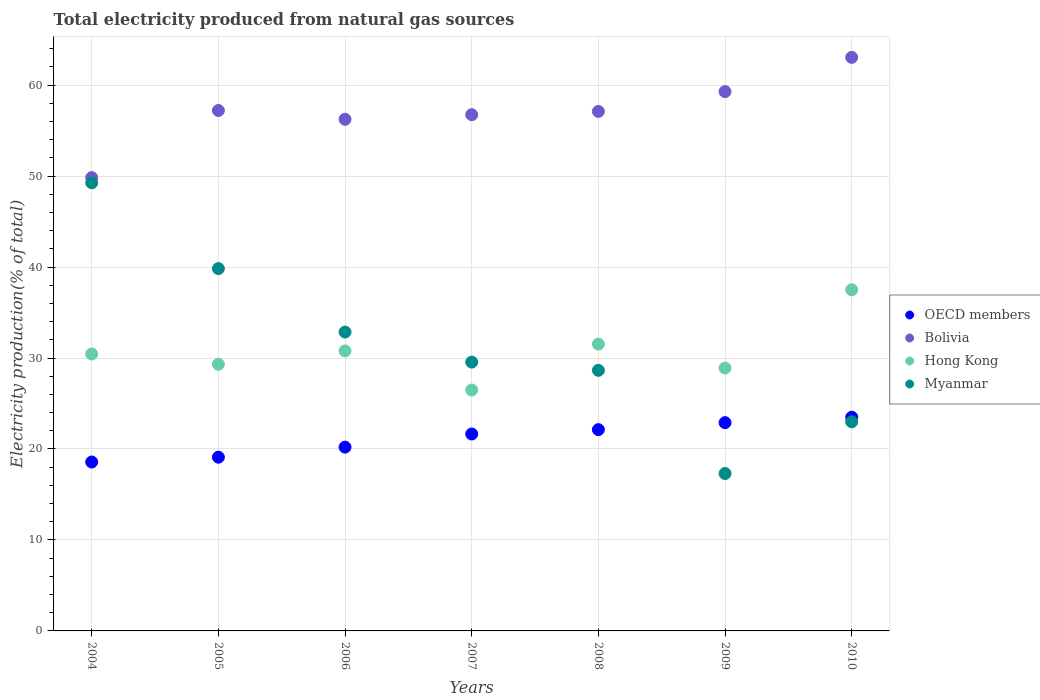How many different coloured dotlines are there?
Your answer should be very brief. 4. Is the number of dotlines equal to the number of legend labels?
Give a very brief answer. Yes. What is the total electricity produced in OECD members in 2008?
Give a very brief answer. 22.13. Across all years, what is the maximum total electricity produced in Hong Kong?
Give a very brief answer. 37.5. Across all years, what is the minimum total electricity produced in OECD members?
Keep it short and to the point. 18.57. In which year was the total electricity produced in Hong Kong maximum?
Offer a very short reply. 2010. In which year was the total electricity produced in Myanmar minimum?
Offer a very short reply. 2009. What is the total total electricity produced in Hong Kong in the graph?
Provide a succinct answer. 214.95. What is the difference between the total electricity produced in Hong Kong in 2006 and that in 2009?
Provide a succinct answer. 1.89. What is the difference between the total electricity produced in Bolivia in 2004 and the total electricity produced in Myanmar in 2010?
Provide a succinct answer. 26.85. What is the average total electricity produced in OECD members per year?
Keep it short and to the point. 21.15. In the year 2006, what is the difference between the total electricity produced in Hong Kong and total electricity produced in OECD members?
Offer a very short reply. 10.58. What is the ratio of the total electricity produced in Hong Kong in 2005 to that in 2008?
Ensure brevity in your answer.  0.93. Is the difference between the total electricity produced in Hong Kong in 2005 and 2007 greater than the difference between the total electricity produced in OECD members in 2005 and 2007?
Keep it short and to the point. Yes. What is the difference between the highest and the second highest total electricity produced in Bolivia?
Ensure brevity in your answer.  3.76. What is the difference between the highest and the lowest total electricity produced in OECD members?
Your answer should be compact. 4.93. In how many years, is the total electricity produced in Bolivia greater than the average total electricity produced in Bolivia taken over all years?
Make the answer very short. 4. Is the sum of the total electricity produced in Bolivia in 2005 and 2006 greater than the maximum total electricity produced in Hong Kong across all years?
Offer a very short reply. Yes. Is it the case that in every year, the sum of the total electricity produced in OECD members and total electricity produced in Myanmar  is greater than the sum of total electricity produced in Hong Kong and total electricity produced in Bolivia?
Give a very brief answer. No. Is the total electricity produced in OECD members strictly greater than the total electricity produced in Bolivia over the years?
Give a very brief answer. No. Is the total electricity produced in Hong Kong strictly less than the total electricity produced in Bolivia over the years?
Offer a terse response. Yes. How many dotlines are there?
Give a very brief answer. 4. Does the graph contain grids?
Keep it short and to the point. Yes. Where does the legend appear in the graph?
Give a very brief answer. Center right. How many legend labels are there?
Offer a terse response. 4. How are the legend labels stacked?
Your response must be concise. Vertical. What is the title of the graph?
Give a very brief answer. Total electricity produced from natural gas sources. Does "Kosovo" appear as one of the legend labels in the graph?
Offer a very short reply. No. What is the label or title of the X-axis?
Offer a very short reply. Years. What is the label or title of the Y-axis?
Provide a succinct answer. Electricity production(% of total). What is the Electricity production(% of total) in OECD members in 2004?
Make the answer very short. 18.57. What is the Electricity production(% of total) of Bolivia in 2004?
Provide a succinct answer. 49.83. What is the Electricity production(% of total) in Hong Kong in 2004?
Your response must be concise. 30.44. What is the Electricity production(% of total) in Myanmar in 2004?
Your answer should be very brief. 49.26. What is the Electricity production(% of total) of OECD members in 2005?
Keep it short and to the point. 19.1. What is the Electricity production(% of total) of Bolivia in 2005?
Give a very brief answer. 57.21. What is the Electricity production(% of total) in Hong Kong in 2005?
Offer a very short reply. 29.31. What is the Electricity production(% of total) in Myanmar in 2005?
Your answer should be compact. 39.83. What is the Electricity production(% of total) in OECD members in 2006?
Provide a succinct answer. 20.2. What is the Electricity production(% of total) of Bolivia in 2006?
Provide a short and direct response. 56.25. What is the Electricity production(% of total) of Hong Kong in 2006?
Offer a very short reply. 30.78. What is the Electricity production(% of total) of Myanmar in 2006?
Your answer should be very brief. 32.85. What is the Electricity production(% of total) in OECD members in 2007?
Provide a short and direct response. 21.65. What is the Electricity production(% of total) of Bolivia in 2007?
Provide a succinct answer. 56.75. What is the Electricity production(% of total) of Hong Kong in 2007?
Your answer should be very brief. 26.48. What is the Electricity production(% of total) of Myanmar in 2007?
Your answer should be very brief. 29.55. What is the Electricity production(% of total) in OECD members in 2008?
Keep it short and to the point. 22.13. What is the Electricity production(% of total) of Bolivia in 2008?
Make the answer very short. 57.11. What is the Electricity production(% of total) in Hong Kong in 2008?
Offer a very short reply. 31.53. What is the Electricity production(% of total) of Myanmar in 2008?
Provide a succinct answer. 28.65. What is the Electricity production(% of total) in OECD members in 2009?
Offer a terse response. 22.9. What is the Electricity production(% of total) of Bolivia in 2009?
Provide a short and direct response. 59.29. What is the Electricity production(% of total) of Hong Kong in 2009?
Make the answer very short. 28.9. What is the Electricity production(% of total) in Myanmar in 2009?
Provide a succinct answer. 17.3. What is the Electricity production(% of total) of OECD members in 2010?
Offer a very short reply. 23.49. What is the Electricity production(% of total) in Bolivia in 2010?
Offer a very short reply. 63.05. What is the Electricity production(% of total) of Hong Kong in 2010?
Offer a terse response. 37.5. What is the Electricity production(% of total) in Myanmar in 2010?
Provide a succinct answer. 22.99. Across all years, what is the maximum Electricity production(% of total) of OECD members?
Give a very brief answer. 23.49. Across all years, what is the maximum Electricity production(% of total) in Bolivia?
Keep it short and to the point. 63.05. Across all years, what is the maximum Electricity production(% of total) of Hong Kong?
Provide a short and direct response. 37.5. Across all years, what is the maximum Electricity production(% of total) in Myanmar?
Make the answer very short. 49.26. Across all years, what is the minimum Electricity production(% of total) of OECD members?
Ensure brevity in your answer.  18.57. Across all years, what is the minimum Electricity production(% of total) of Bolivia?
Make the answer very short. 49.83. Across all years, what is the minimum Electricity production(% of total) in Hong Kong?
Ensure brevity in your answer.  26.48. Across all years, what is the minimum Electricity production(% of total) of Myanmar?
Ensure brevity in your answer.  17.3. What is the total Electricity production(% of total) of OECD members in the graph?
Your answer should be very brief. 148.03. What is the total Electricity production(% of total) of Bolivia in the graph?
Provide a short and direct response. 399.48. What is the total Electricity production(% of total) of Hong Kong in the graph?
Offer a terse response. 214.95. What is the total Electricity production(% of total) of Myanmar in the graph?
Ensure brevity in your answer.  220.43. What is the difference between the Electricity production(% of total) in OECD members in 2004 and that in 2005?
Provide a short and direct response. -0.53. What is the difference between the Electricity production(% of total) of Bolivia in 2004 and that in 2005?
Provide a succinct answer. -7.38. What is the difference between the Electricity production(% of total) in Hong Kong in 2004 and that in 2005?
Offer a terse response. 1.13. What is the difference between the Electricity production(% of total) of Myanmar in 2004 and that in 2005?
Provide a succinct answer. 9.43. What is the difference between the Electricity production(% of total) in OECD members in 2004 and that in 2006?
Your answer should be compact. -1.64. What is the difference between the Electricity production(% of total) of Bolivia in 2004 and that in 2006?
Your response must be concise. -6.41. What is the difference between the Electricity production(% of total) of Hong Kong in 2004 and that in 2006?
Provide a short and direct response. -0.34. What is the difference between the Electricity production(% of total) in Myanmar in 2004 and that in 2006?
Your answer should be very brief. 16.41. What is the difference between the Electricity production(% of total) of OECD members in 2004 and that in 2007?
Your response must be concise. -3.08. What is the difference between the Electricity production(% of total) of Bolivia in 2004 and that in 2007?
Provide a short and direct response. -6.92. What is the difference between the Electricity production(% of total) of Hong Kong in 2004 and that in 2007?
Offer a terse response. 3.96. What is the difference between the Electricity production(% of total) of Myanmar in 2004 and that in 2007?
Make the answer very short. 19.71. What is the difference between the Electricity production(% of total) in OECD members in 2004 and that in 2008?
Keep it short and to the point. -3.56. What is the difference between the Electricity production(% of total) of Bolivia in 2004 and that in 2008?
Offer a terse response. -7.27. What is the difference between the Electricity production(% of total) in Hong Kong in 2004 and that in 2008?
Provide a succinct answer. -1.09. What is the difference between the Electricity production(% of total) in Myanmar in 2004 and that in 2008?
Your answer should be compact. 20.61. What is the difference between the Electricity production(% of total) in OECD members in 2004 and that in 2009?
Your response must be concise. -4.33. What is the difference between the Electricity production(% of total) of Bolivia in 2004 and that in 2009?
Ensure brevity in your answer.  -9.45. What is the difference between the Electricity production(% of total) of Hong Kong in 2004 and that in 2009?
Offer a terse response. 1.55. What is the difference between the Electricity production(% of total) in Myanmar in 2004 and that in 2009?
Your answer should be compact. 31.96. What is the difference between the Electricity production(% of total) in OECD members in 2004 and that in 2010?
Keep it short and to the point. -4.93. What is the difference between the Electricity production(% of total) in Bolivia in 2004 and that in 2010?
Give a very brief answer. -13.21. What is the difference between the Electricity production(% of total) of Hong Kong in 2004 and that in 2010?
Your answer should be compact. -7.06. What is the difference between the Electricity production(% of total) in Myanmar in 2004 and that in 2010?
Your answer should be compact. 26.27. What is the difference between the Electricity production(% of total) of OECD members in 2005 and that in 2006?
Your answer should be very brief. -1.11. What is the difference between the Electricity production(% of total) in Bolivia in 2005 and that in 2006?
Ensure brevity in your answer.  0.96. What is the difference between the Electricity production(% of total) in Hong Kong in 2005 and that in 2006?
Give a very brief answer. -1.47. What is the difference between the Electricity production(% of total) of Myanmar in 2005 and that in 2006?
Provide a succinct answer. 6.98. What is the difference between the Electricity production(% of total) in OECD members in 2005 and that in 2007?
Make the answer very short. -2.55. What is the difference between the Electricity production(% of total) in Bolivia in 2005 and that in 2007?
Provide a short and direct response. 0.46. What is the difference between the Electricity production(% of total) in Hong Kong in 2005 and that in 2007?
Your answer should be very brief. 2.83. What is the difference between the Electricity production(% of total) of Myanmar in 2005 and that in 2007?
Make the answer very short. 10.28. What is the difference between the Electricity production(% of total) in OECD members in 2005 and that in 2008?
Give a very brief answer. -3.03. What is the difference between the Electricity production(% of total) in Bolivia in 2005 and that in 2008?
Offer a terse response. 0.1. What is the difference between the Electricity production(% of total) of Hong Kong in 2005 and that in 2008?
Keep it short and to the point. -2.22. What is the difference between the Electricity production(% of total) in Myanmar in 2005 and that in 2008?
Give a very brief answer. 11.18. What is the difference between the Electricity production(% of total) of OECD members in 2005 and that in 2009?
Ensure brevity in your answer.  -3.8. What is the difference between the Electricity production(% of total) in Bolivia in 2005 and that in 2009?
Offer a very short reply. -2.08. What is the difference between the Electricity production(% of total) of Hong Kong in 2005 and that in 2009?
Give a very brief answer. 0.41. What is the difference between the Electricity production(% of total) in Myanmar in 2005 and that in 2009?
Your response must be concise. 22.52. What is the difference between the Electricity production(% of total) of OECD members in 2005 and that in 2010?
Ensure brevity in your answer.  -4.4. What is the difference between the Electricity production(% of total) of Bolivia in 2005 and that in 2010?
Ensure brevity in your answer.  -5.84. What is the difference between the Electricity production(% of total) in Hong Kong in 2005 and that in 2010?
Keep it short and to the point. -8.19. What is the difference between the Electricity production(% of total) in Myanmar in 2005 and that in 2010?
Your response must be concise. 16.84. What is the difference between the Electricity production(% of total) in OECD members in 2006 and that in 2007?
Your answer should be compact. -1.44. What is the difference between the Electricity production(% of total) in Bolivia in 2006 and that in 2007?
Your response must be concise. -0.5. What is the difference between the Electricity production(% of total) of Hong Kong in 2006 and that in 2007?
Offer a terse response. 4.3. What is the difference between the Electricity production(% of total) of Myanmar in 2006 and that in 2007?
Give a very brief answer. 3.3. What is the difference between the Electricity production(% of total) of OECD members in 2006 and that in 2008?
Your response must be concise. -1.92. What is the difference between the Electricity production(% of total) in Bolivia in 2006 and that in 2008?
Offer a very short reply. -0.86. What is the difference between the Electricity production(% of total) of Hong Kong in 2006 and that in 2008?
Offer a terse response. -0.75. What is the difference between the Electricity production(% of total) in Myanmar in 2006 and that in 2008?
Give a very brief answer. 4.21. What is the difference between the Electricity production(% of total) in OECD members in 2006 and that in 2009?
Offer a very short reply. -2.69. What is the difference between the Electricity production(% of total) in Bolivia in 2006 and that in 2009?
Your response must be concise. -3.04. What is the difference between the Electricity production(% of total) of Hong Kong in 2006 and that in 2009?
Your answer should be very brief. 1.89. What is the difference between the Electricity production(% of total) of Myanmar in 2006 and that in 2009?
Your answer should be compact. 15.55. What is the difference between the Electricity production(% of total) in OECD members in 2006 and that in 2010?
Your response must be concise. -3.29. What is the difference between the Electricity production(% of total) of Bolivia in 2006 and that in 2010?
Provide a succinct answer. -6.8. What is the difference between the Electricity production(% of total) of Hong Kong in 2006 and that in 2010?
Your answer should be compact. -6.72. What is the difference between the Electricity production(% of total) in Myanmar in 2006 and that in 2010?
Give a very brief answer. 9.86. What is the difference between the Electricity production(% of total) in OECD members in 2007 and that in 2008?
Provide a succinct answer. -0.48. What is the difference between the Electricity production(% of total) of Bolivia in 2007 and that in 2008?
Ensure brevity in your answer.  -0.36. What is the difference between the Electricity production(% of total) in Hong Kong in 2007 and that in 2008?
Provide a short and direct response. -5.05. What is the difference between the Electricity production(% of total) of Myanmar in 2007 and that in 2008?
Make the answer very short. 0.9. What is the difference between the Electricity production(% of total) in OECD members in 2007 and that in 2009?
Keep it short and to the point. -1.25. What is the difference between the Electricity production(% of total) of Bolivia in 2007 and that in 2009?
Make the answer very short. -2.54. What is the difference between the Electricity production(% of total) in Hong Kong in 2007 and that in 2009?
Provide a succinct answer. -2.41. What is the difference between the Electricity production(% of total) of Myanmar in 2007 and that in 2009?
Make the answer very short. 12.25. What is the difference between the Electricity production(% of total) in OECD members in 2007 and that in 2010?
Provide a succinct answer. -1.85. What is the difference between the Electricity production(% of total) of Bolivia in 2007 and that in 2010?
Keep it short and to the point. -6.3. What is the difference between the Electricity production(% of total) of Hong Kong in 2007 and that in 2010?
Your response must be concise. -11.02. What is the difference between the Electricity production(% of total) in Myanmar in 2007 and that in 2010?
Your answer should be very brief. 6.56. What is the difference between the Electricity production(% of total) of OECD members in 2008 and that in 2009?
Your response must be concise. -0.77. What is the difference between the Electricity production(% of total) of Bolivia in 2008 and that in 2009?
Offer a terse response. -2.18. What is the difference between the Electricity production(% of total) of Hong Kong in 2008 and that in 2009?
Your answer should be compact. 2.64. What is the difference between the Electricity production(% of total) in Myanmar in 2008 and that in 2009?
Keep it short and to the point. 11.34. What is the difference between the Electricity production(% of total) in OECD members in 2008 and that in 2010?
Ensure brevity in your answer.  -1.37. What is the difference between the Electricity production(% of total) in Bolivia in 2008 and that in 2010?
Your answer should be compact. -5.94. What is the difference between the Electricity production(% of total) of Hong Kong in 2008 and that in 2010?
Keep it short and to the point. -5.97. What is the difference between the Electricity production(% of total) of Myanmar in 2008 and that in 2010?
Offer a very short reply. 5.66. What is the difference between the Electricity production(% of total) in OECD members in 2009 and that in 2010?
Ensure brevity in your answer.  -0.6. What is the difference between the Electricity production(% of total) in Bolivia in 2009 and that in 2010?
Make the answer very short. -3.76. What is the difference between the Electricity production(% of total) of Hong Kong in 2009 and that in 2010?
Provide a succinct answer. -8.61. What is the difference between the Electricity production(% of total) of Myanmar in 2009 and that in 2010?
Offer a very short reply. -5.68. What is the difference between the Electricity production(% of total) in OECD members in 2004 and the Electricity production(% of total) in Bolivia in 2005?
Offer a terse response. -38.64. What is the difference between the Electricity production(% of total) in OECD members in 2004 and the Electricity production(% of total) in Hong Kong in 2005?
Make the answer very short. -10.74. What is the difference between the Electricity production(% of total) of OECD members in 2004 and the Electricity production(% of total) of Myanmar in 2005?
Your answer should be very brief. -21.26. What is the difference between the Electricity production(% of total) of Bolivia in 2004 and the Electricity production(% of total) of Hong Kong in 2005?
Provide a succinct answer. 20.52. What is the difference between the Electricity production(% of total) of Bolivia in 2004 and the Electricity production(% of total) of Myanmar in 2005?
Give a very brief answer. 10.01. What is the difference between the Electricity production(% of total) of Hong Kong in 2004 and the Electricity production(% of total) of Myanmar in 2005?
Offer a terse response. -9.38. What is the difference between the Electricity production(% of total) of OECD members in 2004 and the Electricity production(% of total) of Bolivia in 2006?
Make the answer very short. -37.68. What is the difference between the Electricity production(% of total) in OECD members in 2004 and the Electricity production(% of total) in Hong Kong in 2006?
Your answer should be very brief. -12.22. What is the difference between the Electricity production(% of total) of OECD members in 2004 and the Electricity production(% of total) of Myanmar in 2006?
Offer a terse response. -14.29. What is the difference between the Electricity production(% of total) of Bolivia in 2004 and the Electricity production(% of total) of Hong Kong in 2006?
Provide a succinct answer. 19.05. What is the difference between the Electricity production(% of total) of Bolivia in 2004 and the Electricity production(% of total) of Myanmar in 2006?
Keep it short and to the point. 16.98. What is the difference between the Electricity production(% of total) of Hong Kong in 2004 and the Electricity production(% of total) of Myanmar in 2006?
Provide a succinct answer. -2.41. What is the difference between the Electricity production(% of total) of OECD members in 2004 and the Electricity production(% of total) of Bolivia in 2007?
Offer a terse response. -38.18. What is the difference between the Electricity production(% of total) of OECD members in 2004 and the Electricity production(% of total) of Hong Kong in 2007?
Your answer should be very brief. -7.92. What is the difference between the Electricity production(% of total) of OECD members in 2004 and the Electricity production(% of total) of Myanmar in 2007?
Keep it short and to the point. -10.98. What is the difference between the Electricity production(% of total) in Bolivia in 2004 and the Electricity production(% of total) in Hong Kong in 2007?
Your response must be concise. 23.35. What is the difference between the Electricity production(% of total) of Bolivia in 2004 and the Electricity production(% of total) of Myanmar in 2007?
Provide a short and direct response. 20.28. What is the difference between the Electricity production(% of total) in Hong Kong in 2004 and the Electricity production(% of total) in Myanmar in 2007?
Your response must be concise. 0.89. What is the difference between the Electricity production(% of total) of OECD members in 2004 and the Electricity production(% of total) of Bolivia in 2008?
Your answer should be very brief. -38.54. What is the difference between the Electricity production(% of total) in OECD members in 2004 and the Electricity production(% of total) in Hong Kong in 2008?
Offer a terse response. -12.96. What is the difference between the Electricity production(% of total) in OECD members in 2004 and the Electricity production(% of total) in Myanmar in 2008?
Make the answer very short. -10.08. What is the difference between the Electricity production(% of total) in Bolivia in 2004 and the Electricity production(% of total) in Hong Kong in 2008?
Offer a very short reply. 18.3. What is the difference between the Electricity production(% of total) of Bolivia in 2004 and the Electricity production(% of total) of Myanmar in 2008?
Make the answer very short. 21.19. What is the difference between the Electricity production(% of total) in Hong Kong in 2004 and the Electricity production(% of total) in Myanmar in 2008?
Ensure brevity in your answer.  1.8. What is the difference between the Electricity production(% of total) of OECD members in 2004 and the Electricity production(% of total) of Bolivia in 2009?
Offer a very short reply. -40.72. What is the difference between the Electricity production(% of total) in OECD members in 2004 and the Electricity production(% of total) in Hong Kong in 2009?
Your response must be concise. -10.33. What is the difference between the Electricity production(% of total) of OECD members in 2004 and the Electricity production(% of total) of Myanmar in 2009?
Ensure brevity in your answer.  1.26. What is the difference between the Electricity production(% of total) of Bolivia in 2004 and the Electricity production(% of total) of Hong Kong in 2009?
Provide a short and direct response. 20.94. What is the difference between the Electricity production(% of total) in Bolivia in 2004 and the Electricity production(% of total) in Myanmar in 2009?
Ensure brevity in your answer.  32.53. What is the difference between the Electricity production(% of total) in Hong Kong in 2004 and the Electricity production(% of total) in Myanmar in 2009?
Offer a terse response. 13.14. What is the difference between the Electricity production(% of total) in OECD members in 2004 and the Electricity production(% of total) in Bolivia in 2010?
Offer a very short reply. -44.48. What is the difference between the Electricity production(% of total) in OECD members in 2004 and the Electricity production(% of total) in Hong Kong in 2010?
Give a very brief answer. -18.94. What is the difference between the Electricity production(% of total) in OECD members in 2004 and the Electricity production(% of total) in Myanmar in 2010?
Your answer should be compact. -4.42. What is the difference between the Electricity production(% of total) in Bolivia in 2004 and the Electricity production(% of total) in Hong Kong in 2010?
Offer a terse response. 12.33. What is the difference between the Electricity production(% of total) in Bolivia in 2004 and the Electricity production(% of total) in Myanmar in 2010?
Keep it short and to the point. 26.85. What is the difference between the Electricity production(% of total) in Hong Kong in 2004 and the Electricity production(% of total) in Myanmar in 2010?
Provide a short and direct response. 7.45. What is the difference between the Electricity production(% of total) of OECD members in 2005 and the Electricity production(% of total) of Bolivia in 2006?
Offer a very short reply. -37.15. What is the difference between the Electricity production(% of total) of OECD members in 2005 and the Electricity production(% of total) of Hong Kong in 2006?
Ensure brevity in your answer.  -11.68. What is the difference between the Electricity production(% of total) in OECD members in 2005 and the Electricity production(% of total) in Myanmar in 2006?
Make the answer very short. -13.75. What is the difference between the Electricity production(% of total) in Bolivia in 2005 and the Electricity production(% of total) in Hong Kong in 2006?
Ensure brevity in your answer.  26.43. What is the difference between the Electricity production(% of total) in Bolivia in 2005 and the Electricity production(% of total) in Myanmar in 2006?
Offer a very short reply. 24.36. What is the difference between the Electricity production(% of total) of Hong Kong in 2005 and the Electricity production(% of total) of Myanmar in 2006?
Give a very brief answer. -3.54. What is the difference between the Electricity production(% of total) of OECD members in 2005 and the Electricity production(% of total) of Bolivia in 2007?
Provide a succinct answer. -37.65. What is the difference between the Electricity production(% of total) in OECD members in 2005 and the Electricity production(% of total) in Hong Kong in 2007?
Provide a short and direct response. -7.38. What is the difference between the Electricity production(% of total) in OECD members in 2005 and the Electricity production(% of total) in Myanmar in 2007?
Make the answer very short. -10.45. What is the difference between the Electricity production(% of total) in Bolivia in 2005 and the Electricity production(% of total) in Hong Kong in 2007?
Make the answer very short. 30.73. What is the difference between the Electricity production(% of total) of Bolivia in 2005 and the Electricity production(% of total) of Myanmar in 2007?
Provide a succinct answer. 27.66. What is the difference between the Electricity production(% of total) of Hong Kong in 2005 and the Electricity production(% of total) of Myanmar in 2007?
Your response must be concise. -0.24. What is the difference between the Electricity production(% of total) of OECD members in 2005 and the Electricity production(% of total) of Bolivia in 2008?
Your answer should be very brief. -38.01. What is the difference between the Electricity production(% of total) in OECD members in 2005 and the Electricity production(% of total) in Hong Kong in 2008?
Offer a terse response. -12.43. What is the difference between the Electricity production(% of total) in OECD members in 2005 and the Electricity production(% of total) in Myanmar in 2008?
Your response must be concise. -9.55. What is the difference between the Electricity production(% of total) in Bolivia in 2005 and the Electricity production(% of total) in Hong Kong in 2008?
Offer a terse response. 25.68. What is the difference between the Electricity production(% of total) in Bolivia in 2005 and the Electricity production(% of total) in Myanmar in 2008?
Ensure brevity in your answer.  28.56. What is the difference between the Electricity production(% of total) of Hong Kong in 2005 and the Electricity production(% of total) of Myanmar in 2008?
Offer a very short reply. 0.66. What is the difference between the Electricity production(% of total) in OECD members in 2005 and the Electricity production(% of total) in Bolivia in 2009?
Your answer should be very brief. -40.19. What is the difference between the Electricity production(% of total) in OECD members in 2005 and the Electricity production(% of total) in Hong Kong in 2009?
Offer a terse response. -9.8. What is the difference between the Electricity production(% of total) in OECD members in 2005 and the Electricity production(% of total) in Myanmar in 2009?
Make the answer very short. 1.8. What is the difference between the Electricity production(% of total) of Bolivia in 2005 and the Electricity production(% of total) of Hong Kong in 2009?
Provide a succinct answer. 28.31. What is the difference between the Electricity production(% of total) of Bolivia in 2005 and the Electricity production(% of total) of Myanmar in 2009?
Provide a succinct answer. 39.91. What is the difference between the Electricity production(% of total) of Hong Kong in 2005 and the Electricity production(% of total) of Myanmar in 2009?
Keep it short and to the point. 12.01. What is the difference between the Electricity production(% of total) of OECD members in 2005 and the Electricity production(% of total) of Bolivia in 2010?
Ensure brevity in your answer.  -43.95. What is the difference between the Electricity production(% of total) of OECD members in 2005 and the Electricity production(% of total) of Hong Kong in 2010?
Offer a terse response. -18.41. What is the difference between the Electricity production(% of total) in OECD members in 2005 and the Electricity production(% of total) in Myanmar in 2010?
Your answer should be very brief. -3.89. What is the difference between the Electricity production(% of total) of Bolivia in 2005 and the Electricity production(% of total) of Hong Kong in 2010?
Your response must be concise. 19.71. What is the difference between the Electricity production(% of total) in Bolivia in 2005 and the Electricity production(% of total) in Myanmar in 2010?
Offer a terse response. 34.22. What is the difference between the Electricity production(% of total) of Hong Kong in 2005 and the Electricity production(% of total) of Myanmar in 2010?
Make the answer very short. 6.32. What is the difference between the Electricity production(% of total) of OECD members in 2006 and the Electricity production(% of total) of Bolivia in 2007?
Offer a terse response. -36.54. What is the difference between the Electricity production(% of total) of OECD members in 2006 and the Electricity production(% of total) of Hong Kong in 2007?
Ensure brevity in your answer.  -6.28. What is the difference between the Electricity production(% of total) in OECD members in 2006 and the Electricity production(% of total) in Myanmar in 2007?
Ensure brevity in your answer.  -9.35. What is the difference between the Electricity production(% of total) of Bolivia in 2006 and the Electricity production(% of total) of Hong Kong in 2007?
Your response must be concise. 29.76. What is the difference between the Electricity production(% of total) in Bolivia in 2006 and the Electricity production(% of total) in Myanmar in 2007?
Offer a very short reply. 26.69. What is the difference between the Electricity production(% of total) in Hong Kong in 2006 and the Electricity production(% of total) in Myanmar in 2007?
Provide a succinct answer. 1.23. What is the difference between the Electricity production(% of total) in OECD members in 2006 and the Electricity production(% of total) in Bolivia in 2008?
Your answer should be compact. -36.9. What is the difference between the Electricity production(% of total) of OECD members in 2006 and the Electricity production(% of total) of Hong Kong in 2008?
Your answer should be compact. -11.33. What is the difference between the Electricity production(% of total) in OECD members in 2006 and the Electricity production(% of total) in Myanmar in 2008?
Your answer should be very brief. -8.44. What is the difference between the Electricity production(% of total) of Bolivia in 2006 and the Electricity production(% of total) of Hong Kong in 2008?
Your answer should be very brief. 24.71. What is the difference between the Electricity production(% of total) in Bolivia in 2006 and the Electricity production(% of total) in Myanmar in 2008?
Give a very brief answer. 27.6. What is the difference between the Electricity production(% of total) in Hong Kong in 2006 and the Electricity production(% of total) in Myanmar in 2008?
Ensure brevity in your answer.  2.13. What is the difference between the Electricity production(% of total) of OECD members in 2006 and the Electricity production(% of total) of Bolivia in 2009?
Offer a terse response. -39.08. What is the difference between the Electricity production(% of total) of OECD members in 2006 and the Electricity production(% of total) of Hong Kong in 2009?
Your answer should be very brief. -8.69. What is the difference between the Electricity production(% of total) in OECD members in 2006 and the Electricity production(% of total) in Myanmar in 2009?
Your answer should be very brief. 2.9. What is the difference between the Electricity production(% of total) of Bolivia in 2006 and the Electricity production(% of total) of Hong Kong in 2009?
Provide a succinct answer. 27.35. What is the difference between the Electricity production(% of total) of Bolivia in 2006 and the Electricity production(% of total) of Myanmar in 2009?
Ensure brevity in your answer.  38.94. What is the difference between the Electricity production(% of total) in Hong Kong in 2006 and the Electricity production(% of total) in Myanmar in 2009?
Give a very brief answer. 13.48. What is the difference between the Electricity production(% of total) of OECD members in 2006 and the Electricity production(% of total) of Bolivia in 2010?
Your response must be concise. -42.84. What is the difference between the Electricity production(% of total) in OECD members in 2006 and the Electricity production(% of total) in Hong Kong in 2010?
Ensure brevity in your answer.  -17.3. What is the difference between the Electricity production(% of total) of OECD members in 2006 and the Electricity production(% of total) of Myanmar in 2010?
Ensure brevity in your answer.  -2.78. What is the difference between the Electricity production(% of total) of Bolivia in 2006 and the Electricity production(% of total) of Hong Kong in 2010?
Provide a short and direct response. 18.74. What is the difference between the Electricity production(% of total) of Bolivia in 2006 and the Electricity production(% of total) of Myanmar in 2010?
Give a very brief answer. 33.26. What is the difference between the Electricity production(% of total) in Hong Kong in 2006 and the Electricity production(% of total) in Myanmar in 2010?
Offer a terse response. 7.79. What is the difference between the Electricity production(% of total) of OECD members in 2007 and the Electricity production(% of total) of Bolivia in 2008?
Keep it short and to the point. -35.46. What is the difference between the Electricity production(% of total) of OECD members in 2007 and the Electricity production(% of total) of Hong Kong in 2008?
Ensure brevity in your answer.  -9.88. What is the difference between the Electricity production(% of total) of OECD members in 2007 and the Electricity production(% of total) of Myanmar in 2008?
Provide a succinct answer. -7. What is the difference between the Electricity production(% of total) in Bolivia in 2007 and the Electricity production(% of total) in Hong Kong in 2008?
Your answer should be very brief. 25.22. What is the difference between the Electricity production(% of total) in Bolivia in 2007 and the Electricity production(% of total) in Myanmar in 2008?
Your answer should be compact. 28.1. What is the difference between the Electricity production(% of total) of Hong Kong in 2007 and the Electricity production(% of total) of Myanmar in 2008?
Offer a very short reply. -2.16. What is the difference between the Electricity production(% of total) in OECD members in 2007 and the Electricity production(% of total) in Bolivia in 2009?
Ensure brevity in your answer.  -37.64. What is the difference between the Electricity production(% of total) in OECD members in 2007 and the Electricity production(% of total) in Hong Kong in 2009?
Provide a short and direct response. -7.25. What is the difference between the Electricity production(% of total) in OECD members in 2007 and the Electricity production(% of total) in Myanmar in 2009?
Keep it short and to the point. 4.34. What is the difference between the Electricity production(% of total) in Bolivia in 2007 and the Electricity production(% of total) in Hong Kong in 2009?
Give a very brief answer. 27.85. What is the difference between the Electricity production(% of total) in Bolivia in 2007 and the Electricity production(% of total) in Myanmar in 2009?
Give a very brief answer. 39.45. What is the difference between the Electricity production(% of total) in Hong Kong in 2007 and the Electricity production(% of total) in Myanmar in 2009?
Your response must be concise. 9.18. What is the difference between the Electricity production(% of total) in OECD members in 2007 and the Electricity production(% of total) in Bolivia in 2010?
Keep it short and to the point. -41.4. What is the difference between the Electricity production(% of total) in OECD members in 2007 and the Electricity production(% of total) in Hong Kong in 2010?
Provide a short and direct response. -15.86. What is the difference between the Electricity production(% of total) in OECD members in 2007 and the Electricity production(% of total) in Myanmar in 2010?
Provide a succinct answer. -1.34. What is the difference between the Electricity production(% of total) in Bolivia in 2007 and the Electricity production(% of total) in Hong Kong in 2010?
Provide a succinct answer. 19.25. What is the difference between the Electricity production(% of total) in Bolivia in 2007 and the Electricity production(% of total) in Myanmar in 2010?
Offer a terse response. 33.76. What is the difference between the Electricity production(% of total) of Hong Kong in 2007 and the Electricity production(% of total) of Myanmar in 2010?
Offer a very short reply. 3.5. What is the difference between the Electricity production(% of total) of OECD members in 2008 and the Electricity production(% of total) of Bolivia in 2009?
Offer a terse response. -37.16. What is the difference between the Electricity production(% of total) in OECD members in 2008 and the Electricity production(% of total) in Hong Kong in 2009?
Provide a succinct answer. -6.77. What is the difference between the Electricity production(% of total) of OECD members in 2008 and the Electricity production(% of total) of Myanmar in 2009?
Keep it short and to the point. 4.82. What is the difference between the Electricity production(% of total) of Bolivia in 2008 and the Electricity production(% of total) of Hong Kong in 2009?
Your answer should be compact. 28.21. What is the difference between the Electricity production(% of total) of Bolivia in 2008 and the Electricity production(% of total) of Myanmar in 2009?
Offer a terse response. 39.81. What is the difference between the Electricity production(% of total) in Hong Kong in 2008 and the Electricity production(% of total) in Myanmar in 2009?
Keep it short and to the point. 14.23. What is the difference between the Electricity production(% of total) of OECD members in 2008 and the Electricity production(% of total) of Bolivia in 2010?
Provide a short and direct response. -40.92. What is the difference between the Electricity production(% of total) of OECD members in 2008 and the Electricity production(% of total) of Hong Kong in 2010?
Your answer should be very brief. -15.38. What is the difference between the Electricity production(% of total) in OECD members in 2008 and the Electricity production(% of total) in Myanmar in 2010?
Ensure brevity in your answer.  -0.86. What is the difference between the Electricity production(% of total) in Bolivia in 2008 and the Electricity production(% of total) in Hong Kong in 2010?
Ensure brevity in your answer.  19.6. What is the difference between the Electricity production(% of total) in Bolivia in 2008 and the Electricity production(% of total) in Myanmar in 2010?
Make the answer very short. 34.12. What is the difference between the Electricity production(% of total) of Hong Kong in 2008 and the Electricity production(% of total) of Myanmar in 2010?
Give a very brief answer. 8.54. What is the difference between the Electricity production(% of total) in OECD members in 2009 and the Electricity production(% of total) in Bolivia in 2010?
Give a very brief answer. -40.15. What is the difference between the Electricity production(% of total) of OECD members in 2009 and the Electricity production(% of total) of Hong Kong in 2010?
Your answer should be very brief. -14.61. What is the difference between the Electricity production(% of total) in OECD members in 2009 and the Electricity production(% of total) in Myanmar in 2010?
Give a very brief answer. -0.09. What is the difference between the Electricity production(% of total) in Bolivia in 2009 and the Electricity production(% of total) in Hong Kong in 2010?
Your answer should be compact. 21.78. What is the difference between the Electricity production(% of total) of Bolivia in 2009 and the Electricity production(% of total) of Myanmar in 2010?
Your answer should be compact. 36.3. What is the difference between the Electricity production(% of total) of Hong Kong in 2009 and the Electricity production(% of total) of Myanmar in 2010?
Your response must be concise. 5.91. What is the average Electricity production(% of total) of OECD members per year?
Offer a very short reply. 21.15. What is the average Electricity production(% of total) of Bolivia per year?
Provide a succinct answer. 57.07. What is the average Electricity production(% of total) of Hong Kong per year?
Give a very brief answer. 30.71. What is the average Electricity production(% of total) in Myanmar per year?
Keep it short and to the point. 31.49. In the year 2004, what is the difference between the Electricity production(% of total) in OECD members and Electricity production(% of total) in Bolivia?
Offer a terse response. -31.27. In the year 2004, what is the difference between the Electricity production(% of total) of OECD members and Electricity production(% of total) of Hong Kong?
Offer a very short reply. -11.88. In the year 2004, what is the difference between the Electricity production(% of total) of OECD members and Electricity production(% of total) of Myanmar?
Keep it short and to the point. -30.69. In the year 2004, what is the difference between the Electricity production(% of total) of Bolivia and Electricity production(% of total) of Hong Kong?
Offer a very short reply. 19.39. In the year 2004, what is the difference between the Electricity production(% of total) in Bolivia and Electricity production(% of total) in Myanmar?
Your answer should be compact. 0.57. In the year 2004, what is the difference between the Electricity production(% of total) in Hong Kong and Electricity production(% of total) in Myanmar?
Offer a very short reply. -18.82. In the year 2005, what is the difference between the Electricity production(% of total) of OECD members and Electricity production(% of total) of Bolivia?
Offer a very short reply. -38.11. In the year 2005, what is the difference between the Electricity production(% of total) in OECD members and Electricity production(% of total) in Hong Kong?
Provide a short and direct response. -10.21. In the year 2005, what is the difference between the Electricity production(% of total) of OECD members and Electricity production(% of total) of Myanmar?
Your answer should be compact. -20.73. In the year 2005, what is the difference between the Electricity production(% of total) in Bolivia and Electricity production(% of total) in Hong Kong?
Ensure brevity in your answer.  27.9. In the year 2005, what is the difference between the Electricity production(% of total) in Bolivia and Electricity production(% of total) in Myanmar?
Offer a very short reply. 17.38. In the year 2005, what is the difference between the Electricity production(% of total) of Hong Kong and Electricity production(% of total) of Myanmar?
Your answer should be very brief. -10.52. In the year 2006, what is the difference between the Electricity production(% of total) in OECD members and Electricity production(% of total) in Bolivia?
Provide a succinct answer. -36.04. In the year 2006, what is the difference between the Electricity production(% of total) in OECD members and Electricity production(% of total) in Hong Kong?
Offer a terse response. -10.58. In the year 2006, what is the difference between the Electricity production(% of total) of OECD members and Electricity production(% of total) of Myanmar?
Provide a succinct answer. -12.65. In the year 2006, what is the difference between the Electricity production(% of total) of Bolivia and Electricity production(% of total) of Hong Kong?
Offer a very short reply. 25.46. In the year 2006, what is the difference between the Electricity production(% of total) in Bolivia and Electricity production(% of total) in Myanmar?
Give a very brief answer. 23.39. In the year 2006, what is the difference between the Electricity production(% of total) in Hong Kong and Electricity production(% of total) in Myanmar?
Make the answer very short. -2.07. In the year 2007, what is the difference between the Electricity production(% of total) in OECD members and Electricity production(% of total) in Bolivia?
Ensure brevity in your answer.  -35.1. In the year 2007, what is the difference between the Electricity production(% of total) of OECD members and Electricity production(% of total) of Hong Kong?
Keep it short and to the point. -4.84. In the year 2007, what is the difference between the Electricity production(% of total) of OECD members and Electricity production(% of total) of Myanmar?
Offer a terse response. -7.9. In the year 2007, what is the difference between the Electricity production(% of total) in Bolivia and Electricity production(% of total) in Hong Kong?
Ensure brevity in your answer.  30.27. In the year 2007, what is the difference between the Electricity production(% of total) of Bolivia and Electricity production(% of total) of Myanmar?
Offer a terse response. 27.2. In the year 2007, what is the difference between the Electricity production(% of total) of Hong Kong and Electricity production(% of total) of Myanmar?
Provide a short and direct response. -3.07. In the year 2008, what is the difference between the Electricity production(% of total) of OECD members and Electricity production(% of total) of Bolivia?
Your response must be concise. -34.98. In the year 2008, what is the difference between the Electricity production(% of total) of OECD members and Electricity production(% of total) of Hong Kong?
Ensure brevity in your answer.  -9.4. In the year 2008, what is the difference between the Electricity production(% of total) of OECD members and Electricity production(% of total) of Myanmar?
Your answer should be very brief. -6.52. In the year 2008, what is the difference between the Electricity production(% of total) in Bolivia and Electricity production(% of total) in Hong Kong?
Make the answer very short. 25.58. In the year 2008, what is the difference between the Electricity production(% of total) in Bolivia and Electricity production(% of total) in Myanmar?
Your response must be concise. 28.46. In the year 2008, what is the difference between the Electricity production(% of total) in Hong Kong and Electricity production(% of total) in Myanmar?
Your answer should be very brief. 2.88. In the year 2009, what is the difference between the Electricity production(% of total) of OECD members and Electricity production(% of total) of Bolivia?
Your answer should be very brief. -36.39. In the year 2009, what is the difference between the Electricity production(% of total) of OECD members and Electricity production(% of total) of Hong Kong?
Give a very brief answer. -6. In the year 2009, what is the difference between the Electricity production(% of total) of OECD members and Electricity production(% of total) of Myanmar?
Your response must be concise. 5.59. In the year 2009, what is the difference between the Electricity production(% of total) in Bolivia and Electricity production(% of total) in Hong Kong?
Provide a succinct answer. 30.39. In the year 2009, what is the difference between the Electricity production(% of total) of Bolivia and Electricity production(% of total) of Myanmar?
Offer a very short reply. 41.98. In the year 2009, what is the difference between the Electricity production(% of total) of Hong Kong and Electricity production(% of total) of Myanmar?
Give a very brief answer. 11.59. In the year 2010, what is the difference between the Electricity production(% of total) in OECD members and Electricity production(% of total) in Bolivia?
Offer a very short reply. -39.55. In the year 2010, what is the difference between the Electricity production(% of total) in OECD members and Electricity production(% of total) in Hong Kong?
Provide a succinct answer. -14.01. In the year 2010, what is the difference between the Electricity production(% of total) of OECD members and Electricity production(% of total) of Myanmar?
Provide a succinct answer. 0.51. In the year 2010, what is the difference between the Electricity production(% of total) in Bolivia and Electricity production(% of total) in Hong Kong?
Offer a very short reply. 25.54. In the year 2010, what is the difference between the Electricity production(% of total) of Bolivia and Electricity production(% of total) of Myanmar?
Offer a terse response. 40.06. In the year 2010, what is the difference between the Electricity production(% of total) in Hong Kong and Electricity production(% of total) in Myanmar?
Provide a succinct answer. 14.52. What is the ratio of the Electricity production(% of total) in OECD members in 2004 to that in 2005?
Provide a succinct answer. 0.97. What is the ratio of the Electricity production(% of total) of Bolivia in 2004 to that in 2005?
Ensure brevity in your answer.  0.87. What is the ratio of the Electricity production(% of total) of Hong Kong in 2004 to that in 2005?
Your answer should be compact. 1.04. What is the ratio of the Electricity production(% of total) in Myanmar in 2004 to that in 2005?
Your answer should be very brief. 1.24. What is the ratio of the Electricity production(% of total) of OECD members in 2004 to that in 2006?
Make the answer very short. 0.92. What is the ratio of the Electricity production(% of total) of Bolivia in 2004 to that in 2006?
Your answer should be compact. 0.89. What is the ratio of the Electricity production(% of total) of Hong Kong in 2004 to that in 2006?
Provide a short and direct response. 0.99. What is the ratio of the Electricity production(% of total) in Myanmar in 2004 to that in 2006?
Your response must be concise. 1.5. What is the ratio of the Electricity production(% of total) of OECD members in 2004 to that in 2007?
Ensure brevity in your answer.  0.86. What is the ratio of the Electricity production(% of total) of Bolivia in 2004 to that in 2007?
Your answer should be very brief. 0.88. What is the ratio of the Electricity production(% of total) of Hong Kong in 2004 to that in 2007?
Give a very brief answer. 1.15. What is the ratio of the Electricity production(% of total) of Myanmar in 2004 to that in 2007?
Ensure brevity in your answer.  1.67. What is the ratio of the Electricity production(% of total) in OECD members in 2004 to that in 2008?
Keep it short and to the point. 0.84. What is the ratio of the Electricity production(% of total) of Bolivia in 2004 to that in 2008?
Make the answer very short. 0.87. What is the ratio of the Electricity production(% of total) in Hong Kong in 2004 to that in 2008?
Provide a short and direct response. 0.97. What is the ratio of the Electricity production(% of total) of Myanmar in 2004 to that in 2008?
Give a very brief answer. 1.72. What is the ratio of the Electricity production(% of total) in OECD members in 2004 to that in 2009?
Keep it short and to the point. 0.81. What is the ratio of the Electricity production(% of total) in Bolivia in 2004 to that in 2009?
Provide a succinct answer. 0.84. What is the ratio of the Electricity production(% of total) in Hong Kong in 2004 to that in 2009?
Keep it short and to the point. 1.05. What is the ratio of the Electricity production(% of total) of Myanmar in 2004 to that in 2009?
Provide a succinct answer. 2.85. What is the ratio of the Electricity production(% of total) in OECD members in 2004 to that in 2010?
Ensure brevity in your answer.  0.79. What is the ratio of the Electricity production(% of total) of Bolivia in 2004 to that in 2010?
Offer a very short reply. 0.79. What is the ratio of the Electricity production(% of total) in Hong Kong in 2004 to that in 2010?
Offer a terse response. 0.81. What is the ratio of the Electricity production(% of total) of Myanmar in 2004 to that in 2010?
Make the answer very short. 2.14. What is the ratio of the Electricity production(% of total) of OECD members in 2005 to that in 2006?
Make the answer very short. 0.95. What is the ratio of the Electricity production(% of total) in Bolivia in 2005 to that in 2006?
Give a very brief answer. 1.02. What is the ratio of the Electricity production(% of total) in Hong Kong in 2005 to that in 2006?
Ensure brevity in your answer.  0.95. What is the ratio of the Electricity production(% of total) of Myanmar in 2005 to that in 2006?
Offer a very short reply. 1.21. What is the ratio of the Electricity production(% of total) in OECD members in 2005 to that in 2007?
Your answer should be compact. 0.88. What is the ratio of the Electricity production(% of total) of Hong Kong in 2005 to that in 2007?
Ensure brevity in your answer.  1.11. What is the ratio of the Electricity production(% of total) in Myanmar in 2005 to that in 2007?
Make the answer very short. 1.35. What is the ratio of the Electricity production(% of total) in OECD members in 2005 to that in 2008?
Your answer should be compact. 0.86. What is the ratio of the Electricity production(% of total) of Bolivia in 2005 to that in 2008?
Your response must be concise. 1. What is the ratio of the Electricity production(% of total) in Hong Kong in 2005 to that in 2008?
Provide a short and direct response. 0.93. What is the ratio of the Electricity production(% of total) of Myanmar in 2005 to that in 2008?
Offer a very short reply. 1.39. What is the ratio of the Electricity production(% of total) in OECD members in 2005 to that in 2009?
Your response must be concise. 0.83. What is the ratio of the Electricity production(% of total) in Bolivia in 2005 to that in 2009?
Provide a succinct answer. 0.96. What is the ratio of the Electricity production(% of total) in Hong Kong in 2005 to that in 2009?
Provide a short and direct response. 1.01. What is the ratio of the Electricity production(% of total) of Myanmar in 2005 to that in 2009?
Your answer should be compact. 2.3. What is the ratio of the Electricity production(% of total) in OECD members in 2005 to that in 2010?
Offer a terse response. 0.81. What is the ratio of the Electricity production(% of total) in Bolivia in 2005 to that in 2010?
Ensure brevity in your answer.  0.91. What is the ratio of the Electricity production(% of total) in Hong Kong in 2005 to that in 2010?
Your answer should be very brief. 0.78. What is the ratio of the Electricity production(% of total) of Myanmar in 2005 to that in 2010?
Provide a short and direct response. 1.73. What is the ratio of the Electricity production(% of total) of OECD members in 2006 to that in 2007?
Offer a terse response. 0.93. What is the ratio of the Electricity production(% of total) in Bolivia in 2006 to that in 2007?
Your response must be concise. 0.99. What is the ratio of the Electricity production(% of total) of Hong Kong in 2006 to that in 2007?
Offer a terse response. 1.16. What is the ratio of the Electricity production(% of total) in Myanmar in 2006 to that in 2007?
Provide a succinct answer. 1.11. What is the ratio of the Electricity production(% of total) in OECD members in 2006 to that in 2008?
Your answer should be very brief. 0.91. What is the ratio of the Electricity production(% of total) of Bolivia in 2006 to that in 2008?
Your answer should be very brief. 0.98. What is the ratio of the Electricity production(% of total) of Hong Kong in 2006 to that in 2008?
Your answer should be very brief. 0.98. What is the ratio of the Electricity production(% of total) in Myanmar in 2006 to that in 2008?
Your answer should be very brief. 1.15. What is the ratio of the Electricity production(% of total) of OECD members in 2006 to that in 2009?
Offer a very short reply. 0.88. What is the ratio of the Electricity production(% of total) in Bolivia in 2006 to that in 2009?
Your answer should be compact. 0.95. What is the ratio of the Electricity production(% of total) of Hong Kong in 2006 to that in 2009?
Your response must be concise. 1.07. What is the ratio of the Electricity production(% of total) in Myanmar in 2006 to that in 2009?
Provide a succinct answer. 1.9. What is the ratio of the Electricity production(% of total) of OECD members in 2006 to that in 2010?
Your response must be concise. 0.86. What is the ratio of the Electricity production(% of total) of Bolivia in 2006 to that in 2010?
Your answer should be compact. 0.89. What is the ratio of the Electricity production(% of total) of Hong Kong in 2006 to that in 2010?
Provide a short and direct response. 0.82. What is the ratio of the Electricity production(% of total) in Myanmar in 2006 to that in 2010?
Offer a terse response. 1.43. What is the ratio of the Electricity production(% of total) of OECD members in 2007 to that in 2008?
Ensure brevity in your answer.  0.98. What is the ratio of the Electricity production(% of total) in Hong Kong in 2007 to that in 2008?
Provide a short and direct response. 0.84. What is the ratio of the Electricity production(% of total) in Myanmar in 2007 to that in 2008?
Your answer should be very brief. 1.03. What is the ratio of the Electricity production(% of total) in OECD members in 2007 to that in 2009?
Provide a succinct answer. 0.95. What is the ratio of the Electricity production(% of total) in Bolivia in 2007 to that in 2009?
Make the answer very short. 0.96. What is the ratio of the Electricity production(% of total) in Hong Kong in 2007 to that in 2009?
Provide a short and direct response. 0.92. What is the ratio of the Electricity production(% of total) of Myanmar in 2007 to that in 2009?
Ensure brevity in your answer.  1.71. What is the ratio of the Electricity production(% of total) in OECD members in 2007 to that in 2010?
Your answer should be compact. 0.92. What is the ratio of the Electricity production(% of total) in Bolivia in 2007 to that in 2010?
Make the answer very short. 0.9. What is the ratio of the Electricity production(% of total) in Hong Kong in 2007 to that in 2010?
Keep it short and to the point. 0.71. What is the ratio of the Electricity production(% of total) of Myanmar in 2007 to that in 2010?
Your answer should be compact. 1.29. What is the ratio of the Electricity production(% of total) in OECD members in 2008 to that in 2009?
Ensure brevity in your answer.  0.97. What is the ratio of the Electricity production(% of total) of Bolivia in 2008 to that in 2009?
Keep it short and to the point. 0.96. What is the ratio of the Electricity production(% of total) in Hong Kong in 2008 to that in 2009?
Your response must be concise. 1.09. What is the ratio of the Electricity production(% of total) of Myanmar in 2008 to that in 2009?
Provide a succinct answer. 1.66. What is the ratio of the Electricity production(% of total) of OECD members in 2008 to that in 2010?
Keep it short and to the point. 0.94. What is the ratio of the Electricity production(% of total) of Bolivia in 2008 to that in 2010?
Offer a terse response. 0.91. What is the ratio of the Electricity production(% of total) of Hong Kong in 2008 to that in 2010?
Your answer should be compact. 0.84. What is the ratio of the Electricity production(% of total) in Myanmar in 2008 to that in 2010?
Your response must be concise. 1.25. What is the ratio of the Electricity production(% of total) in OECD members in 2009 to that in 2010?
Offer a terse response. 0.97. What is the ratio of the Electricity production(% of total) of Bolivia in 2009 to that in 2010?
Make the answer very short. 0.94. What is the ratio of the Electricity production(% of total) of Hong Kong in 2009 to that in 2010?
Offer a very short reply. 0.77. What is the ratio of the Electricity production(% of total) of Myanmar in 2009 to that in 2010?
Keep it short and to the point. 0.75. What is the difference between the highest and the second highest Electricity production(% of total) of OECD members?
Keep it short and to the point. 0.6. What is the difference between the highest and the second highest Electricity production(% of total) in Bolivia?
Offer a very short reply. 3.76. What is the difference between the highest and the second highest Electricity production(% of total) in Hong Kong?
Your response must be concise. 5.97. What is the difference between the highest and the second highest Electricity production(% of total) of Myanmar?
Make the answer very short. 9.43. What is the difference between the highest and the lowest Electricity production(% of total) of OECD members?
Your response must be concise. 4.93. What is the difference between the highest and the lowest Electricity production(% of total) of Bolivia?
Your answer should be very brief. 13.21. What is the difference between the highest and the lowest Electricity production(% of total) of Hong Kong?
Offer a terse response. 11.02. What is the difference between the highest and the lowest Electricity production(% of total) of Myanmar?
Provide a succinct answer. 31.96. 